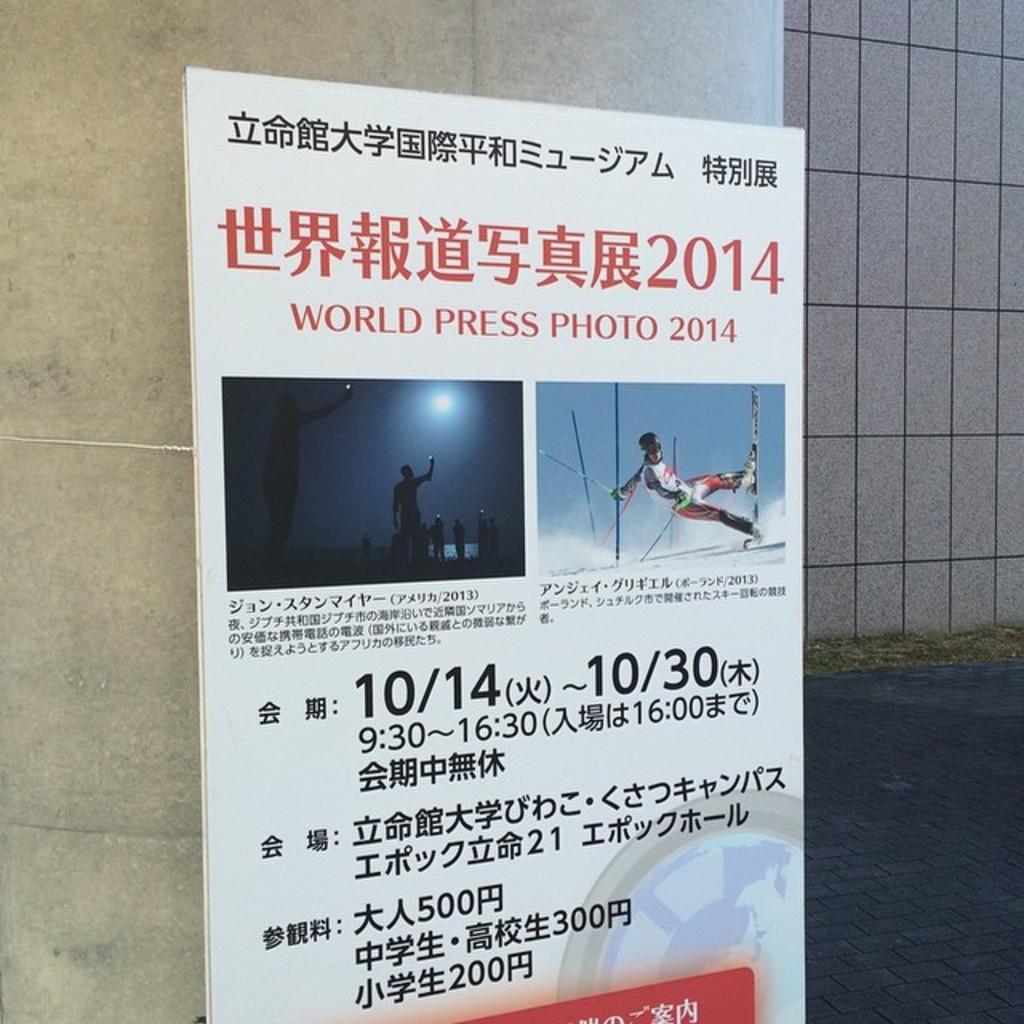What year is this event?
Your answer should be compact. 2014. What year is on the poster?
Make the answer very short. 2014. 